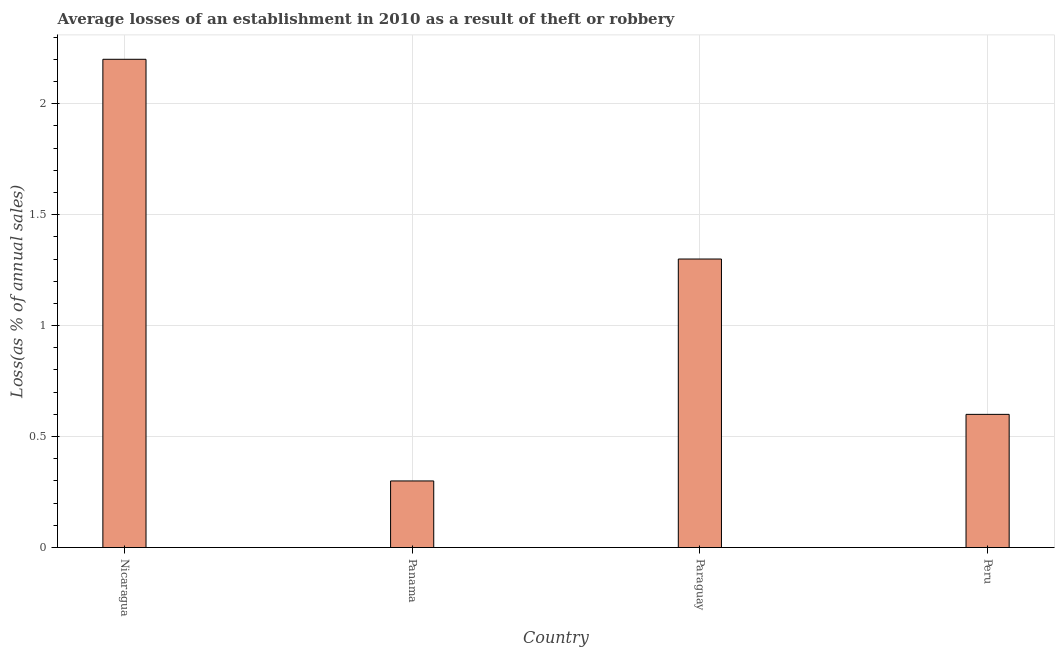Does the graph contain any zero values?
Offer a terse response. No. Does the graph contain grids?
Ensure brevity in your answer.  Yes. What is the title of the graph?
Ensure brevity in your answer.  Average losses of an establishment in 2010 as a result of theft or robbery. What is the label or title of the X-axis?
Offer a very short reply. Country. What is the label or title of the Y-axis?
Keep it short and to the point. Loss(as % of annual sales). What is the losses due to theft in Peru?
Your answer should be compact. 0.6. In which country was the losses due to theft maximum?
Your answer should be very brief. Nicaragua. In which country was the losses due to theft minimum?
Your response must be concise. Panama. What is the sum of the losses due to theft?
Give a very brief answer. 4.4. In how many countries, is the losses due to theft greater than 1.1 %?
Your answer should be very brief. 2. What is the ratio of the losses due to theft in Panama to that in Paraguay?
Offer a very short reply. 0.23. What is the difference between the highest and the second highest losses due to theft?
Keep it short and to the point. 0.9. What is the difference between the highest and the lowest losses due to theft?
Offer a terse response. 1.9. In how many countries, is the losses due to theft greater than the average losses due to theft taken over all countries?
Your answer should be very brief. 2. Are all the bars in the graph horizontal?
Provide a short and direct response. No. What is the difference between two consecutive major ticks on the Y-axis?
Give a very brief answer. 0.5. Are the values on the major ticks of Y-axis written in scientific E-notation?
Provide a succinct answer. No. What is the Loss(as % of annual sales) of Panama?
Offer a very short reply. 0.3. What is the difference between the Loss(as % of annual sales) in Nicaragua and Paraguay?
Keep it short and to the point. 0.9. What is the difference between the Loss(as % of annual sales) in Panama and Paraguay?
Offer a terse response. -1. What is the difference between the Loss(as % of annual sales) in Panama and Peru?
Offer a very short reply. -0.3. What is the ratio of the Loss(as % of annual sales) in Nicaragua to that in Panama?
Your response must be concise. 7.33. What is the ratio of the Loss(as % of annual sales) in Nicaragua to that in Paraguay?
Provide a succinct answer. 1.69. What is the ratio of the Loss(as % of annual sales) in Nicaragua to that in Peru?
Offer a very short reply. 3.67. What is the ratio of the Loss(as % of annual sales) in Panama to that in Paraguay?
Your answer should be very brief. 0.23. What is the ratio of the Loss(as % of annual sales) in Paraguay to that in Peru?
Offer a terse response. 2.17. 